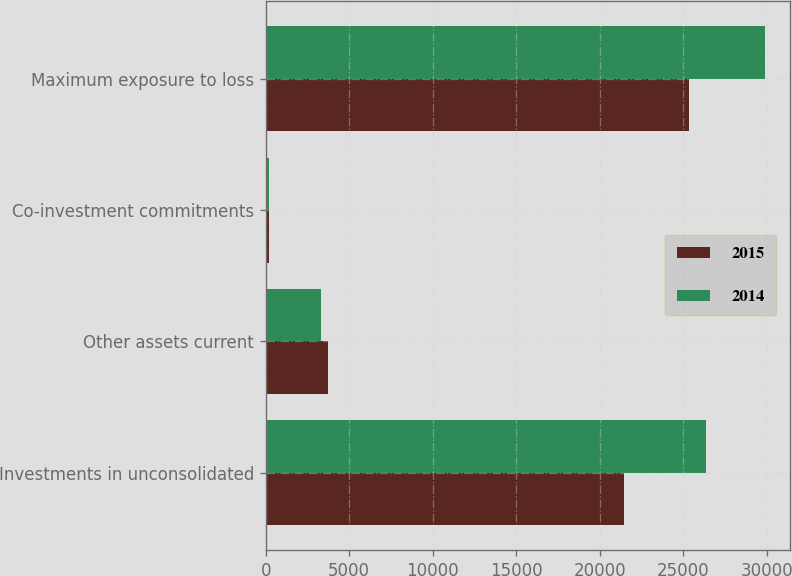<chart> <loc_0><loc_0><loc_500><loc_500><stacked_bar_chart><ecel><fcel>Investments in unconsolidated<fcel>Other assets current<fcel>Co-investment commitments<fcel>Maximum exposure to loss<nl><fcel>2015<fcel>21457<fcel>3723<fcel>180<fcel>25360<nl><fcel>2014<fcel>26353<fcel>3337<fcel>200<fcel>29890<nl></chart> 